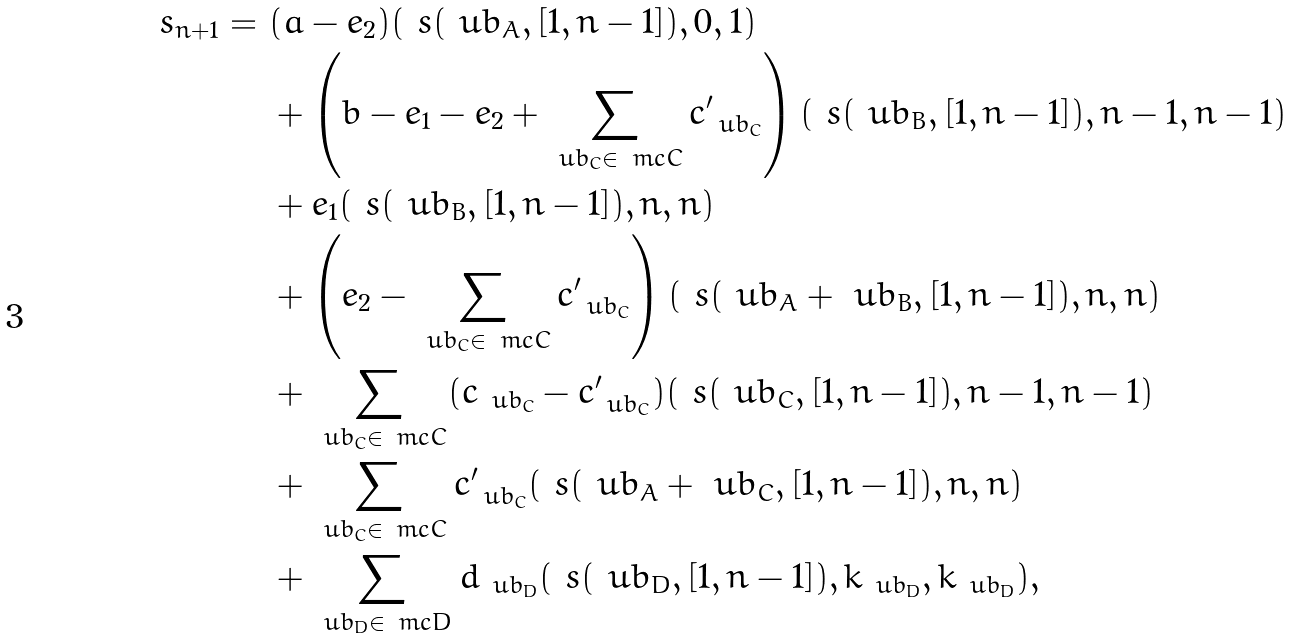Convert formula to latex. <formula><loc_0><loc_0><loc_500><loc_500>\ s _ { n + 1 } = \ & ( a - e _ { 2 } ) ( \ s ( \ u b _ { A } , [ 1 , n - 1 ] ) , 0 , 1 ) \\ & + \left ( b - e _ { 1 } - e _ { 2 } + \sum _ { \ u b _ { C } \in \ m c { C } } c ^ { \prime } _ { \ u b _ { C } } \right ) ( \ s ( \ u b _ { B } , [ 1 , n - 1 ] ) , n - 1 , n - 1 ) \\ & + e _ { 1 } ( \ s ( \ u b _ { B } , [ 1 , n - 1 ] ) , n , n ) \\ & + \left ( e _ { 2 } - \sum _ { \ u b _ { C } \in \ m c { C } } c ^ { \prime } _ { \ u b _ { C } } \right ) ( \ s ( \ u b _ { A } + \ u b _ { B } , [ 1 , n - 1 ] ) , n , n ) \\ & + \sum _ { \ u b _ { C } \in \ m c { C } } ( c _ { \ u b _ { C } } - c ^ { \prime } _ { \ u b _ { C } } ) ( \ s ( \ u b _ { C } , [ 1 , n - 1 ] ) , n - 1 , n - 1 ) \\ & + \sum _ { \ u b _ { C } \in \ m c { C } } c ^ { \prime } _ { \ u b _ { C } } ( \ s ( \ u b _ { A } + \ u b _ { C } , [ 1 , n - 1 ] ) , n , n ) \\ & + \sum _ { \ u b _ { D } \in \ m c { D } } d _ { \ u b _ { D } } ( \ s ( \ u b _ { D } , [ 1 , n - 1 ] ) , k _ { \ u b _ { D } } , k _ { \ u b _ { D } } ) ,</formula> 